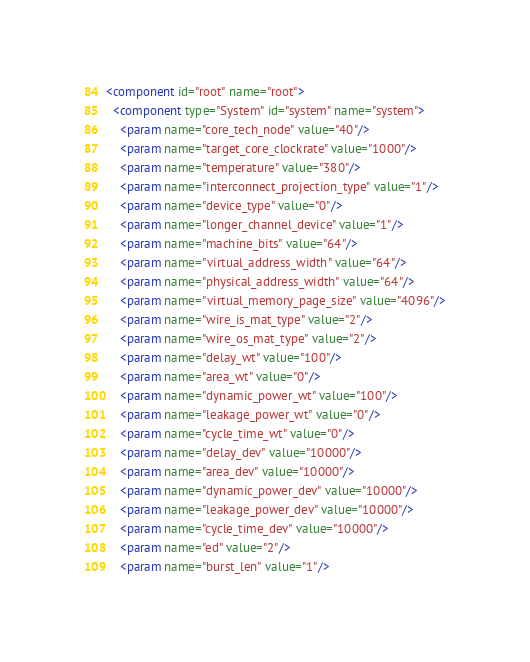<code> <loc_0><loc_0><loc_500><loc_500><_XML_><component id="root" name="root">
  <component type="System" id="system" name="system">
    <param name="core_tech_node" value="40"/>
    <param name="target_core_clockrate" value="1000"/>
    <param name="temperature" value="380"/>
    <param name="interconnect_projection_type" value="1"/>
    <param name="device_type" value="0"/>
    <param name="longer_channel_device" value="1"/>
    <param name="machine_bits" value="64"/>
    <param name="virtual_address_width" value="64"/>
    <param name="physical_address_width" value="64"/>
    <param name="virtual_memory_page_size" value="4096"/>
    <param name="wire_is_mat_type" value="2"/>
    <param name="wire_os_mat_type" value="2"/>
    <param name="delay_wt" value="100"/>
    <param name="area_wt" value="0"/>
    <param name="dynamic_power_wt" value="100"/>
    <param name="leakage_power_wt" value="0"/>
    <param name="cycle_time_wt" value="0"/>
    <param name="delay_dev" value="10000"/>
    <param name="area_dev" value="10000"/>
    <param name="dynamic_power_dev" value="10000"/>
    <param name="leakage_power_dev" value="10000"/>
    <param name="cycle_time_dev" value="10000"/>
    <param name="ed" value="2"/>
    <param name="burst_len" value="1"/></code> 